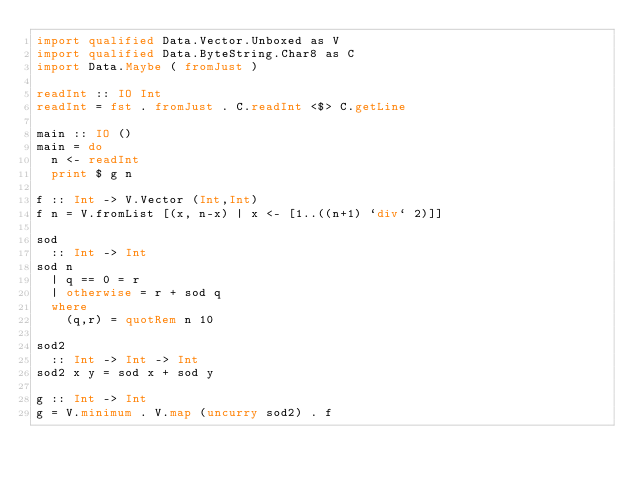<code> <loc_0><loc_0><loc_500><loc_500><_Haskell_>import qualified Data.Vector.Unboxed as V
import qualified Data.ByteString.Char8 as C
import Data.Maybe ( fromJust )

readInt :: IO Int
readInt = fst . fromJust . C.readInt <$> C.getLine

main :: IO ()
main = do
  n <- readInt
  print $ g n

f :: Int -> V.Vector (Int,Int)
f n = V.fromList [(x, n-x) | x <- [1..((n+1) `div` 2)]]

sod
  :: Int -> Int
sod n
  | q == 0 = r 
  | otherwise = r + sod q
  where
    (q,r) = quotRem n 10

sod2
  :: Int -> Int -> Int
sod2 x y = sod x + sod y

g :: Int -> Int
g = V.minimum . V.map (uncurry sod2) . f</code> 